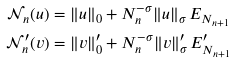Convert formula to latex. <formula><loc_0><loc_0><loc_500><loc_500>\mathcal { N } _ { n } ( u ) & = \| u \| _ { 0 } + N _ { n } ^ { - \sigma } \| u \| _ { \sigma } \, E _ { N _ { n + 1 } } \\ \mathcal { N } _ { n } ^ { \prime } ( v ) & = \| v \| _ { 0 } ^ { \prime } + N _ { n } ^ { - \sigma } \| v \| _ { \sigma } ^ { \prime } \, E _ { N _ { n + 1 } } ^ { \prime }</formula> 